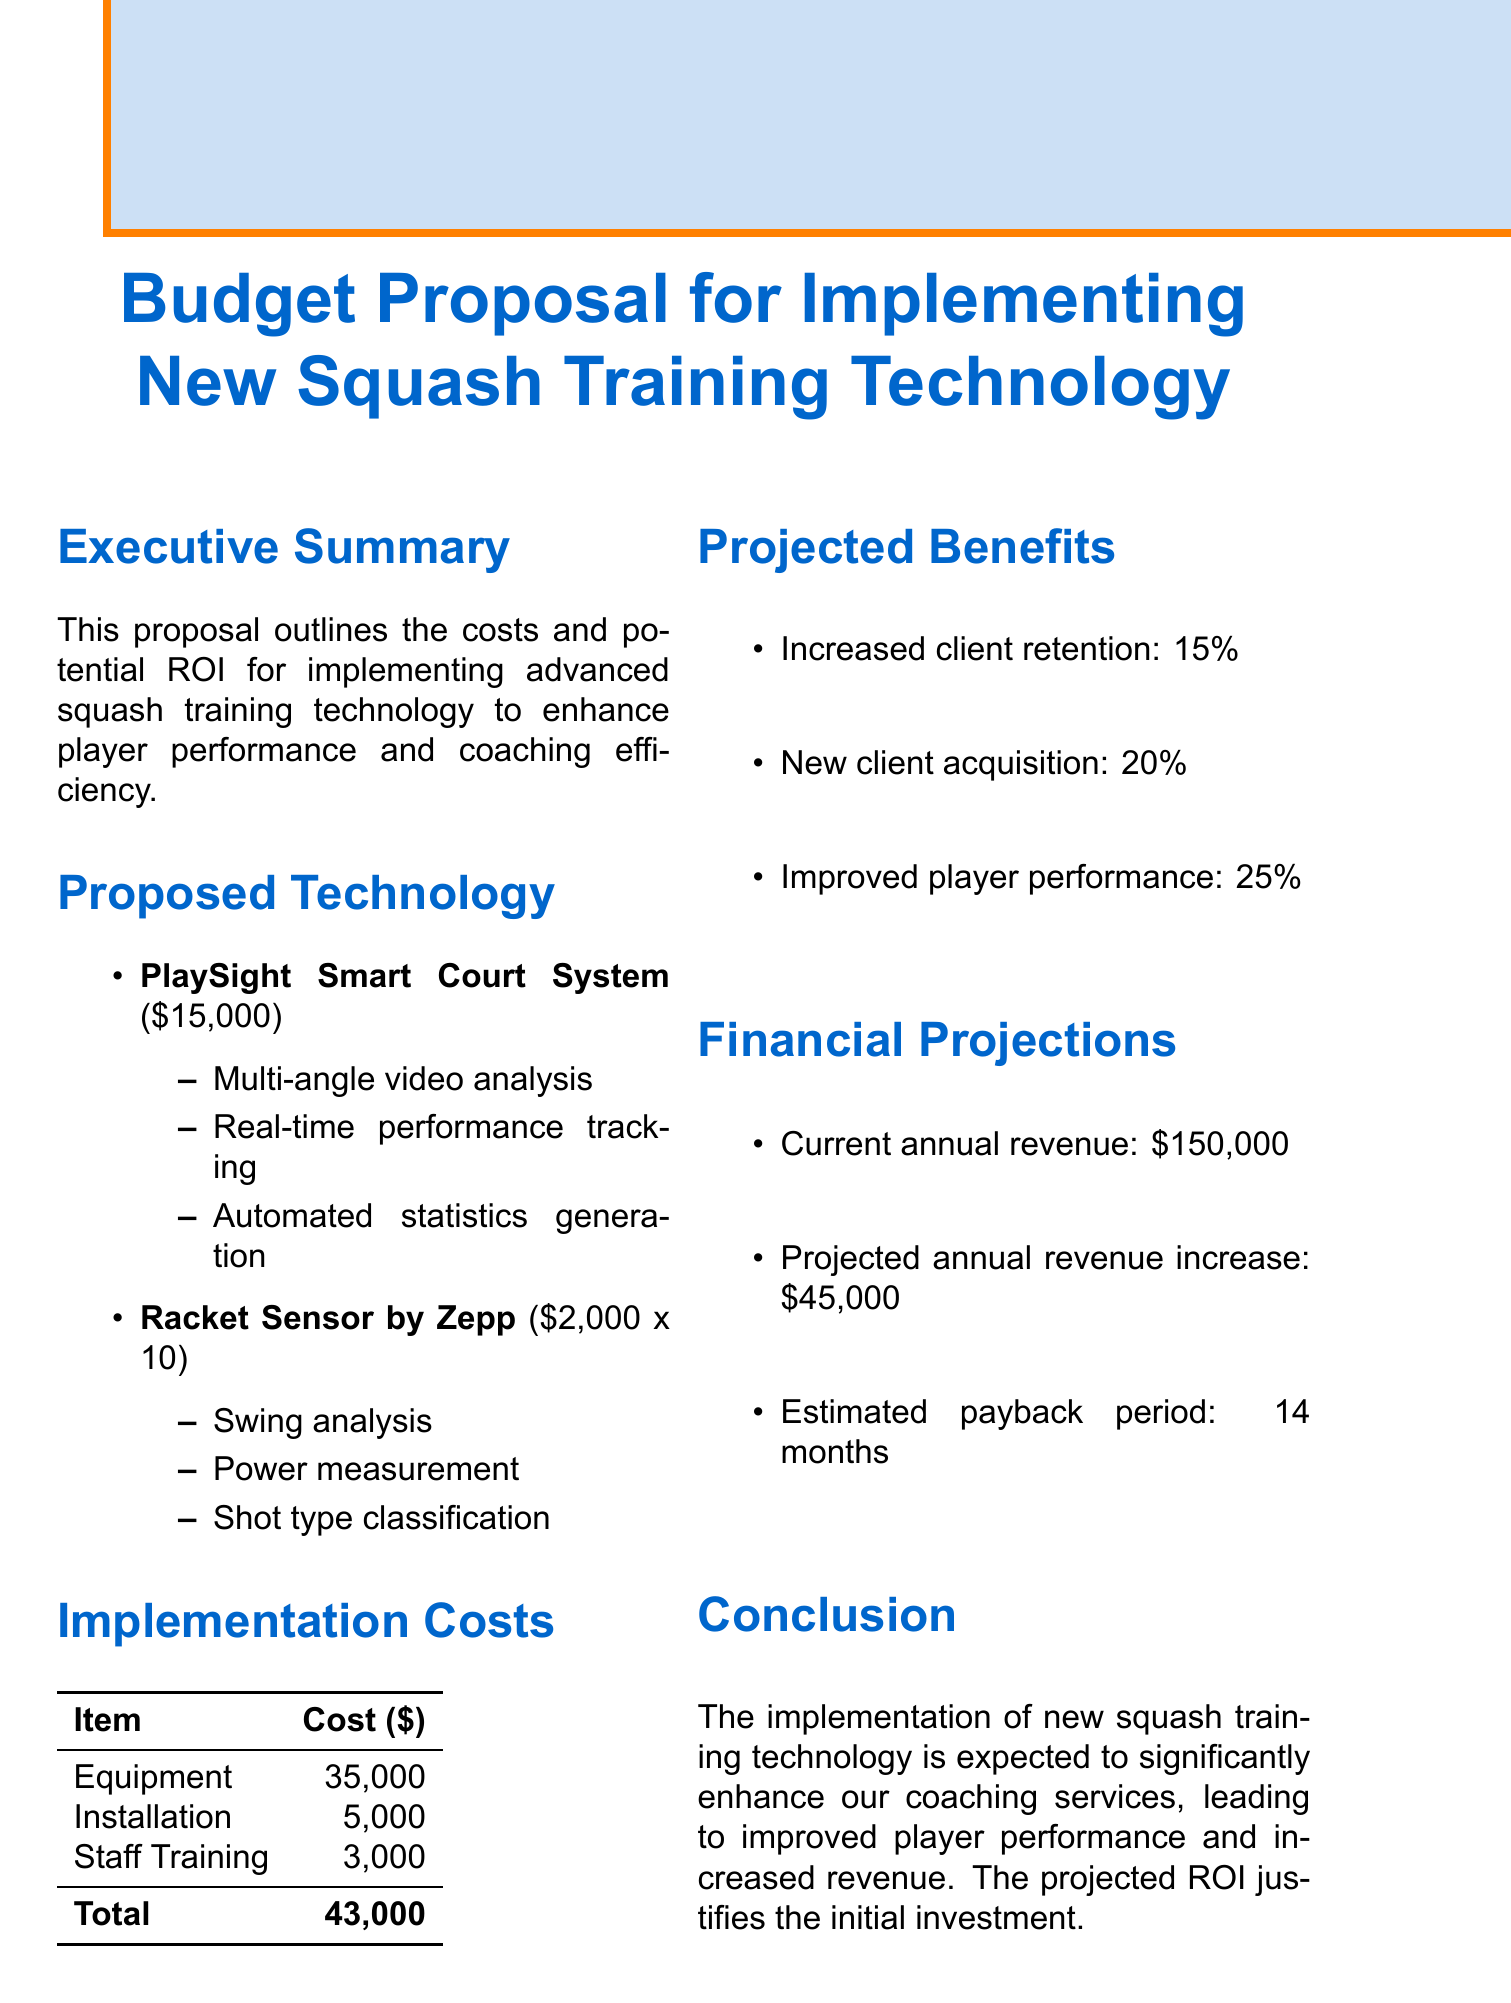What is the title of the document? The title is clearly stated at the beginning of the document as the main heading.
Answer: Budget Proposal for Implementing New Squash Training Technology What is the cost of the PlaySight Smart Court System? The cost is mentioned specifically under the proposed technology section.
Answer: 15000 How much will staff training cost? The cost for staff training is listed in the implementation costs section.
Answer: 3000 What is the projected annual revenue increase? This figure is found in the financial projections section and indicates potential benefits.
Answer: 45000 What percentage increase in client retention is projected? This percentage is noted under the projected benefits section regarding client retention.
Answer: 15% What is the total implementation cost? The total cost is summarized in the implementation costs section.
Answer: 43000 What is the estimated payback period for the investment? The estimated payback period is indicated under the financial projections section.
Answer: 14 months What feature does the Racket Sensor by Zepp provide? This feature is listed specifically in the proposed technology section.
Answer: Swing analysis What are the projected benefits of the proposed technology? The document outlines several benefits in a dedicated section.
Answer: Increased client retention, new client acquisition, improved player performance What is the current annual revenue? This figure is included in the financial projections section of the document.
Answer: 150000 